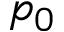<formula> <loc_0><loc_0><loc_500><loc_500>p _ { 0 }</formula> 